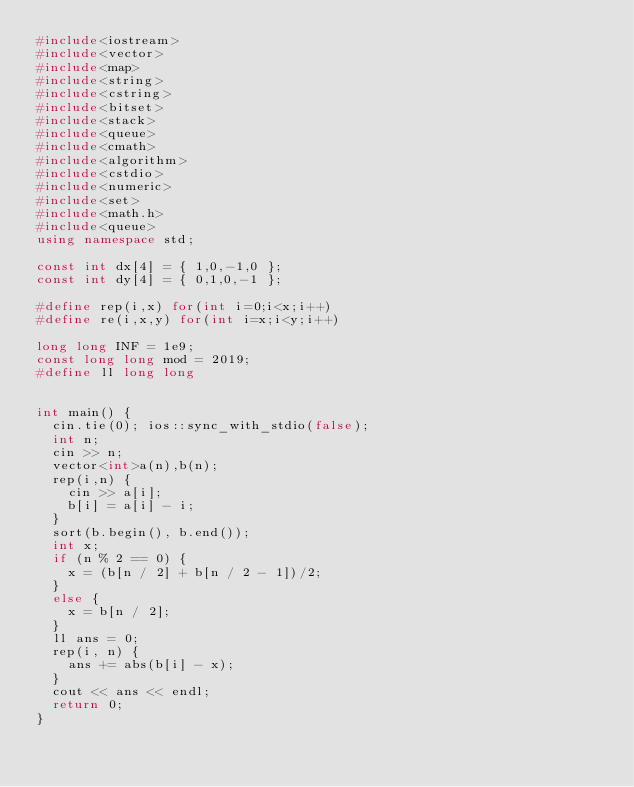Convert code to text. <code><loc_0><loc_0><loc_500><loc_500><_C++_>#include<iostream>
#include<vector>
#include<map>
#include<string>
#include<cstring>
#include<bitset>
#include<stack>
#include<queue>
#include<cmath>
#include<algorithm>
#include<cstdio>
#include<numeric>
#include<set>
#include<math.h>
#include<queue>
using namespace std;

const int dx[4] = { 1,0,-1,0 };
const int dy[4] = { 0,1,0,-1 };

#define rep(i,x) for(int i=0;i<x;i++)
#define re(i,x,y) for(int i=x;i<y;i++)

long long INF = 1e9;
const long long mod = 2019;
#define ll long long


int main() {
	cin.tie(0); ios::sync_with_stdio(false);
	int n;
	cin >> n;
	vector<int>a(n),b(n);
	rep(i,n) {
		cin >> a[i];
		b[i] = a[i] - i;
	}
	sort(b.begin(), b.end());
	int x;
	if (n % 2 == 0) {
		x = (b[n / 2] + b[n / 2 - 1])/2;
	}
	else {
		x = b[n / 2];
	}
	ll ans = 0;
	rep(i, n) {
		ans += abs(b[i] - x);
	}
	cout << ans << endl;
	return 0;
}</code> 